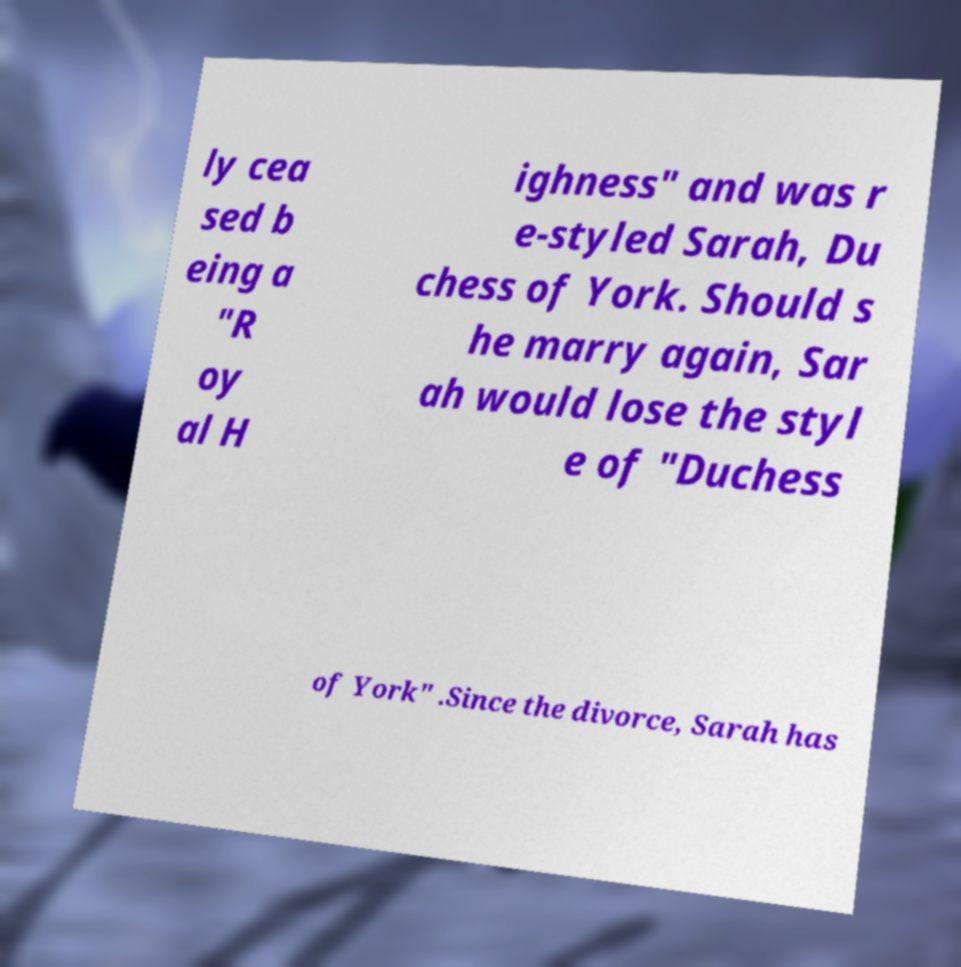I need the written content from this picture converted into text. Can you do that? ly cea sed b eing a "R oy al H ighness" and was r e-styled Sarah, Du chess of York. Should s he marry again, Sar ah would lose the styl e of "Duchess of York" .Since the divorce, Sarah has 